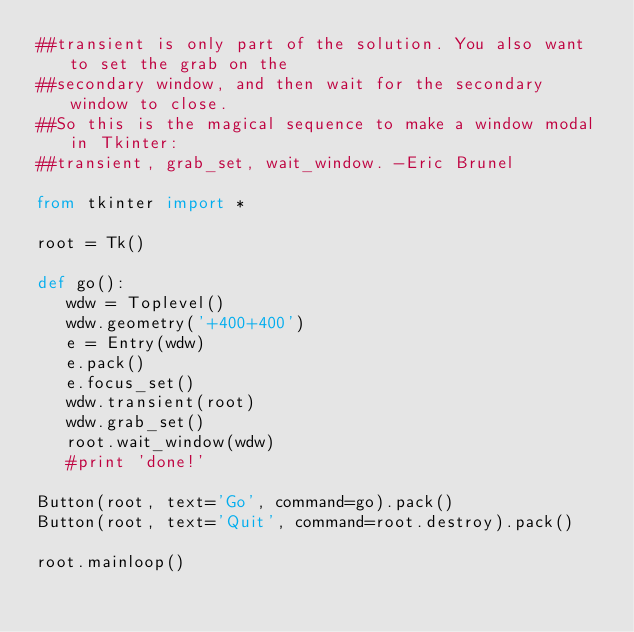<code> <loc_0><loc_0><loc_500><loc_500><_Python_>##transient is only part of the solution. You also want to set the grab on the
##secondary window, and then wait for the secondary window to close.
##So this is the magical sequence to make a window modal in Tkinter:
##transient, grab_set, wait_window. -Eric Brunel

from tkinter import *

root = Tk()

def go():
   wdw = Toplevel()
   wdw.geometry('+400+400')
   e = Entry(wdw)
   e.pack()
   e.focus_set()
   wdw.transient(root)
   wdw.grab_set()
   root.wait_window(wdw)
   #print 'done!'

Button(root, text='Go', command=go).pack()
Button(root, text='Quit', command=root.destroy).pack()

root.mainloop()
</code> 